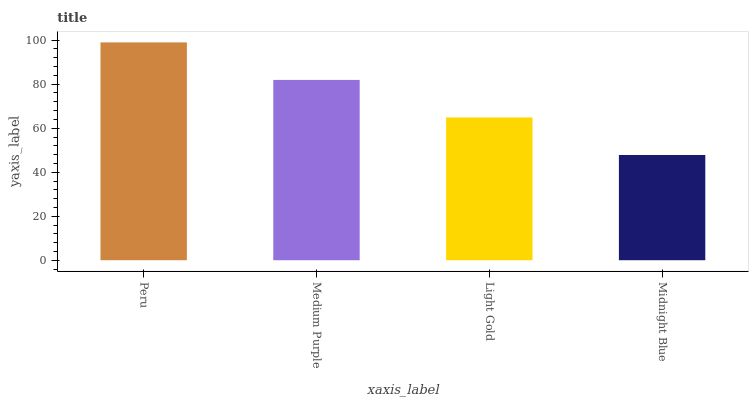Is Midnight Blue the minimum?
Answer yes or no. Yes. Is Peru the maximum?
Answer yes or no. Yes. Is Medium Purple the minimum?
Answer yes or no. No. Is Medium Purple the maximum?
Answer yes or no. No. Is Peru greater than Medium Purple?
Answer yes or no. Yes. Is Medium Purple less than Peru?
Answer yes or no. Yes. Is Medium Purple greater than Peru?
Answer yes or no. No. Is Peru less than Medium Purple?
Answer yes or no. No. Is Medium Purple the high median?
Answer yes or no. Yes. Is Light Gold the low median?
Answer yes or no. Yes. Is Peru the high median?
Answer yes or no. No. Is Medium Purple the low median?
Answer yes or no. No. 